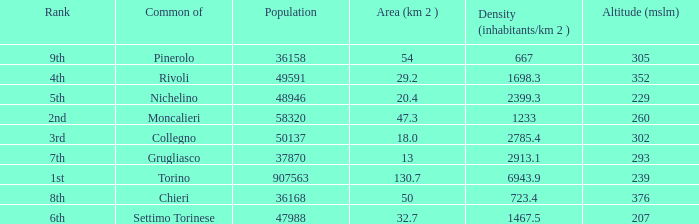How may population figures are given for Settimo Torinese 1.0. 